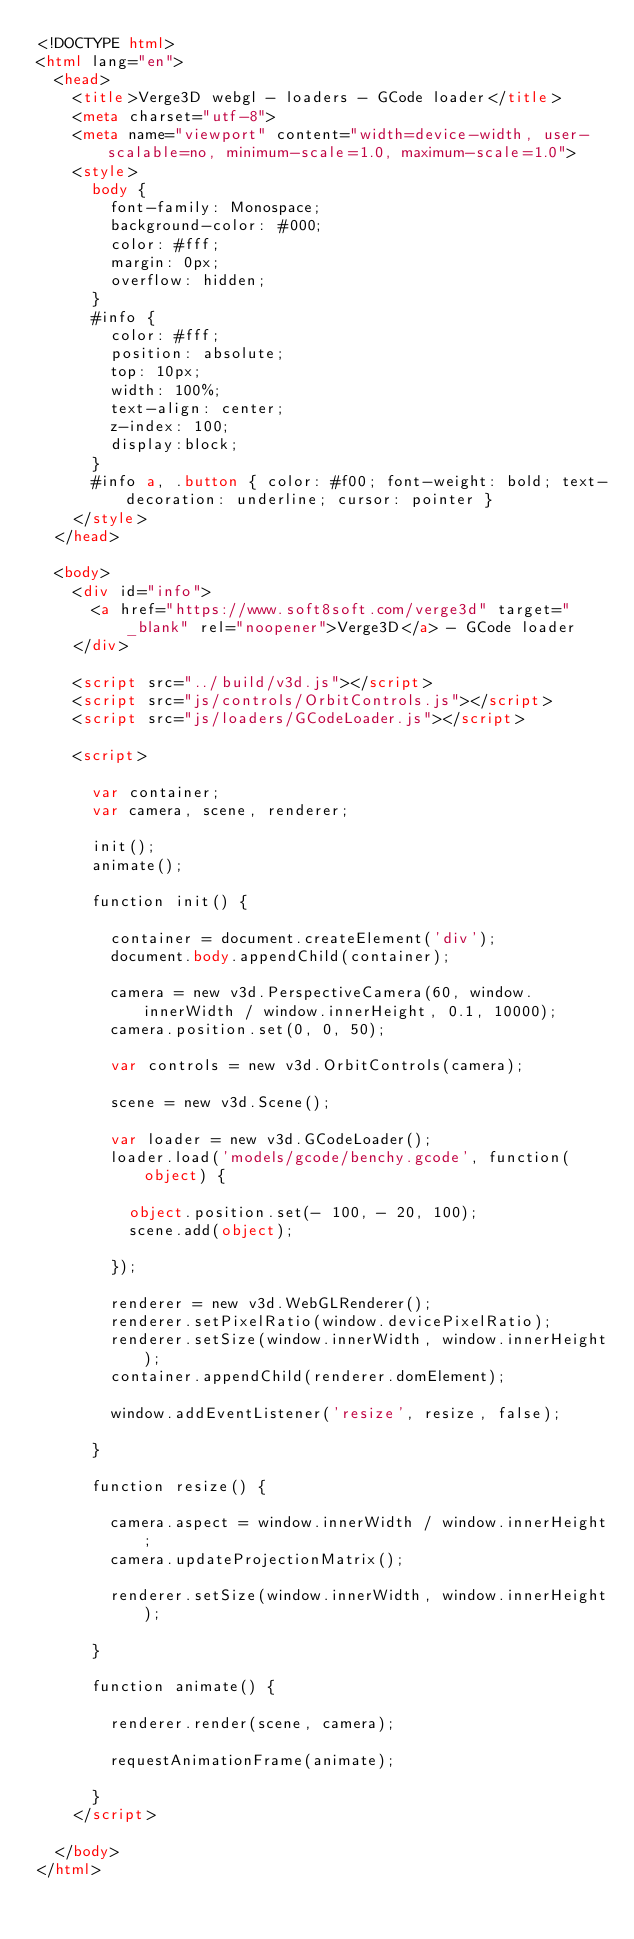Convert code to text. <code><loc_0><loc_0><loc_500><loc_500><_HTML_><!DOCTYPE html>
<html lang="en">
  <head>
    <title>Verge3D webgl - loaders - GCode loader</title>
    <meta charset="utf-8">
    <meta name="viewport" content="width=device-width, user-scalable=no, minimum-scale=1.0, maximum-scale=1.0">
    <style>
      body {
        font-family: Monospace;
        background-color: #000;
        color: #fff;
        margin: 0px;
        overflow: hidden;
      }
      #info {
        color: #fff;
        position: absolute;
        top: 10px;
        width: 100%;
        text-align: center;
        z-index: 100;
        display:block;
      }
      #info a, .button { color: #f00; font-weight: bold; text-decoration: underline; cursor: pointer }
    </style>
  </head>

  <body>
    <div id="info">
      <a href="https://www.soft8soft.com/verge3d" target="_blank" rel="noopener">Verge3D</a> - GCode loader
    </div>

    <script src="../build/v3d.js"></script>
    <script src="js/controls/OrbitControls.js"></script>
    <script src="js/loaders/GCodeLoader.js"></script>

    <script>

      var container;
      var camera, scene, renderer;

      init();
      animate();

      function init() {

        container = document.createElement('div');
        document.body.appendChild(container);

        camera = new v3d.PerspectiveCamera(60, window.innerWidth / window.innerHeight, 0.1, 10000);
        camera.position.set(0, 0, 50);

        var controls = new v3d.OrbitControls(camera);

        scene = new v3d.Scene();

        var loader = new v3d.GCodeLoader();
        loader.load('models/gcode/benchy.gcode', function(object) {

          object.position.set(- 100, - 20, 100);
          scene.add(object);

        });

        renderer = new v3d.WebGLRenderer();
        renderer.setPixelRatio(window.devicePixelRatio);
        renderer.setSize(window.innerWidth, window.innerHeight);
        container.appendChild(renderer.domElement);

        window.addEventListener('resize', resize, false);

      }

      function resize() {

        camera.aspect = window.innerWidth / window.innerHeight;
        camera.updateProjectionMatrix();

        renderer.setSize(window.innerWidth, window.innerHeight);

      }

      function animate() {

        renderer.render(scene, camera);

        requestAnimationFrame(animate);

      }
    </script>

  </body>
</html>
</code> 